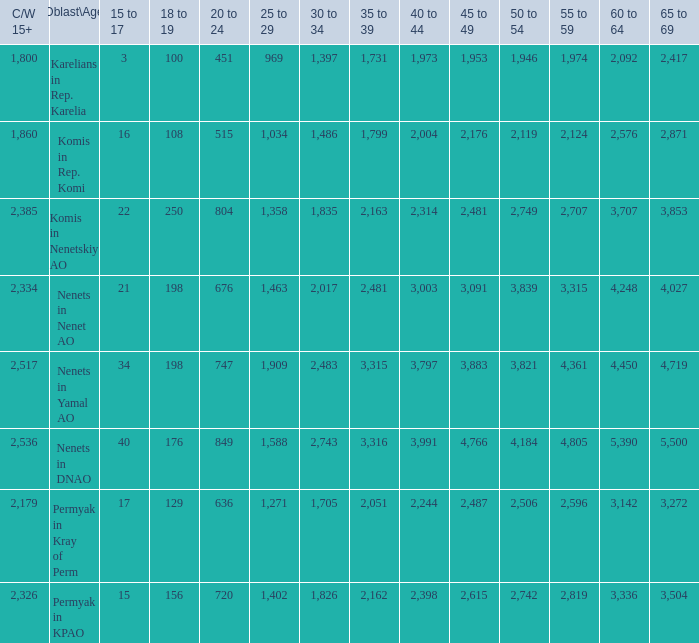What is the overall 30 to 34 when the 40 to 44 interval is more than 3,003, and the 50 to 54 interval is above 4,184? None. 